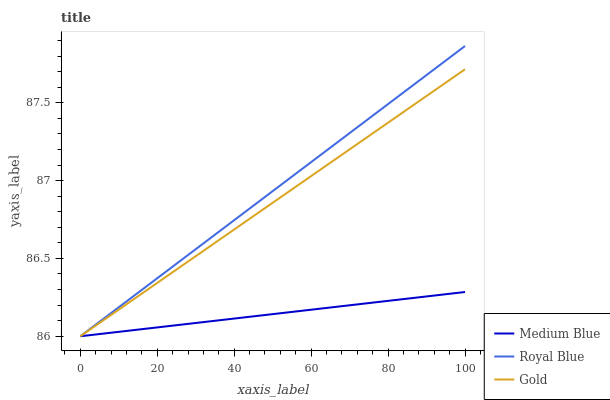Does Medium Blue have the minimum area under the curve?
Answer yes or no. Yes. Does Royal Blue have the maximum area under the curve?
Answer yes or no. Yes. Does Gold have the minimum area under the curve?
Answer yes or no. No. Does Gold have the maximum area under the curve?
Answer yes or no. No. Is Gold the smoothest?
Answer yes or no. Yes. Is Royal Blue the roughest?
Answer yes or no. Yes. Is Medium Blue the smoothest?
Answer yes or no. No. Is Medium Blue the roughest?
Answer yes or no. No. Does Royal Blue have the lowest value?
Answer yes or no. Yes. Does Royal Blue have the highest value?
Answer yes or no. Yes. Does Gold have the highest value?
Answer yes or no. No. Does Gold intersect Royal Blue?
Answer yes or no. Yes. Is Gold less than Royal Blue?
Answer yes or no. No. Is Gold greater than Royal Blue?
Answer yes or no. No. 